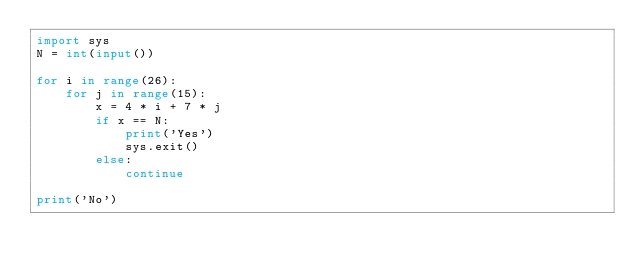Convert code to text. <code><loc_0><loc_0><loc_500><loc_500><_Python_>import sys
N = int(input())

for i in range(26):
    for j in range(15):
        x = 4 * i + 7 * j
        if x == N:
            print('Yes')
            sys.exit()
        else:
            continue

print('No')</code> 